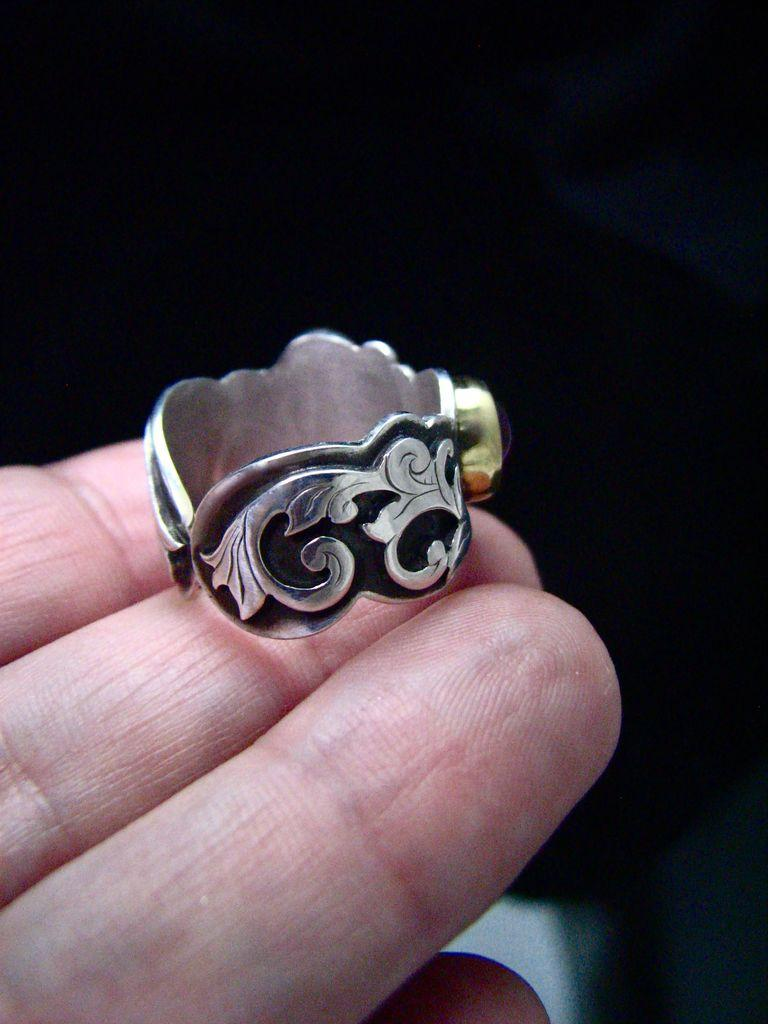What is the main subject of the image? The main subject of the image is a hand. To whom does the hand belong? The hand belongs to a person. What is on the hand? There is a ring on the hand. What color is the background of the image? The background of the image is black. How many kittens are visible in the image? There are no kittens present in the image. What emotion does the person feel based on the presence of the ring in the image? The image does not provide any information about the person's emotions or the significance of the ring. 